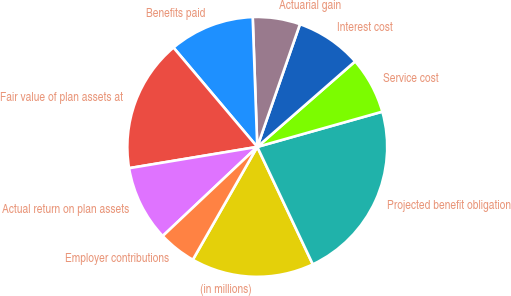<chart> <loc_0><loc_0><loc_500><loc_500><pie_chart><fcel>(in millions)<fcel>Projected benefit obligation<fcel>Service cost<fcel>Interest cost<fcel>Actuarial gain<fcel>Benefits paid<fcel>Fair value of plan assets at<fcel>Actual return on plan assets<fcel>Employer contributions<nl><fcel>15.29%<fcel>22.34%<fcel>7.06%<fcel>8.24%<fcel>5.89%<fcel>10.59%<fcel>16.47%<fcel>9.41%<fcel>4.71%<nl></chart> 